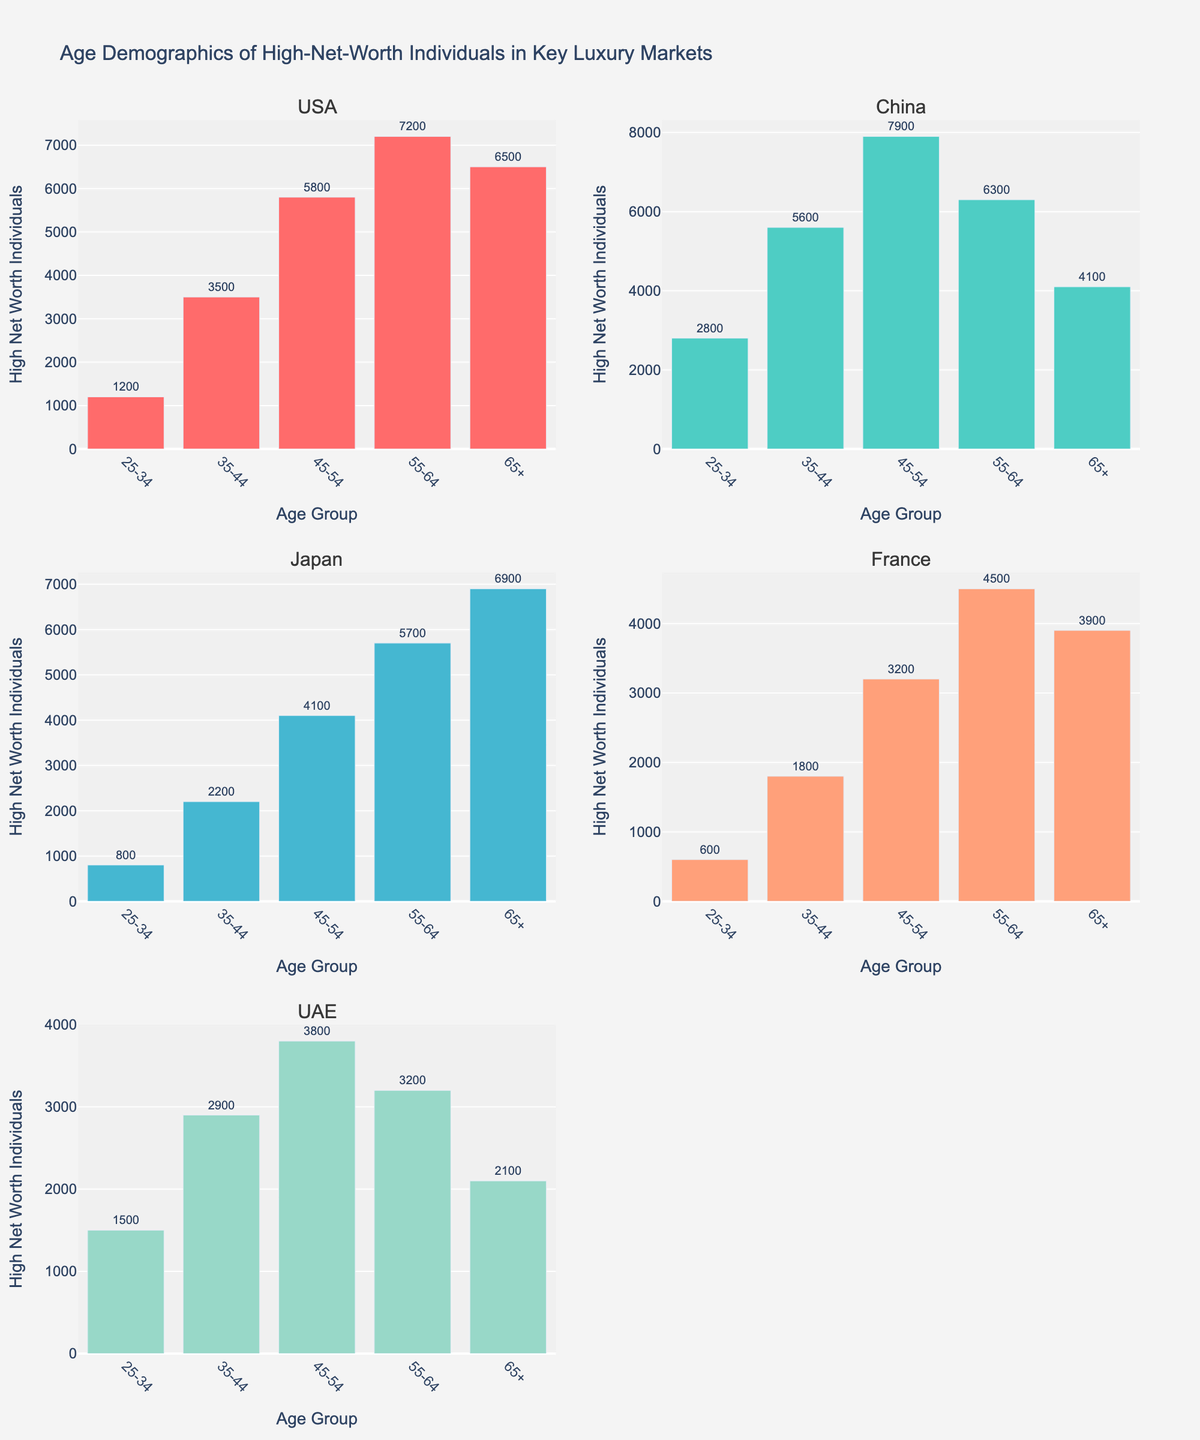Which country has the highest number of high-net-worth individuals in the 45-54 age group? Look at the respective bar heights for the 45-54 age group across all the countries and compare them. China has the tallest bar in this age group.
Answer: China How many high-net-worth individuals are there in France in the 55-64 age group? Locate the bar corresponding to the 55-64 age group for France and read the value. The bar extends to 4500 individuals.
Answer: 4500 What is the combined number of high-net-worth individuals in the 55-64 age group for USA and Japan? Add the values of high-net-worth individuals in the 55-64 age group for both USA and Japan. USA has 7200, and Japan has 5700. So, 7200 + 5700 = 12900.
Answer: 12900 Between the USA and China, which country has more high-net-worth individuals aged 65+? Compare the heights of the bars for the 65+ age group for USA and China. USA has 6500, while China has 4100. USA has more in this age group.
Answer: USA What is the trend of the number of high-net-worth individuals as age increases in the UAE? Observe the bar heights for UAE as the age progresses from 25-34 to 65+. The numbers initially increase from 25-34 to 45-54, then decrease from 45-54 to 65+.
Answer: Increase to 45-54, then decrease Which age group has the smallest population of high-net-worth individuals in Japan? Identify the shortest bar in the subplot for Japan. The 25-34 age group has the shortest bar with 800 individuals.
Answer: 25-34 What’s the total number of high-net-worth individuals across all age groups in China? Sum the values of high-net-worth individuals across all age groups in China: 2800 + 5600 + 7900 + 6300 + 4100 = 26700.
Answer: 26700 Compare the 35-44 age group populations between France and UAE. Which has more high-net-worth individuals? By how much? Compare the bar heights for the 35-44 age group between France and UAE. UAE has 2900, and France has 1800. The difference is 2900 - 1800 = 1100 in favor of UAE.
Answer: UAE by 1100 What is the average number of high-net-worth individuals in the 25-34 age group across all countries? Sum the values of the 25-34 age group for all countries and divide by the number of countries: (1200 + 2800 + 800 + 600 + 1500) / 5 = 6900 / 5 = 1380.
Answer: 1380 